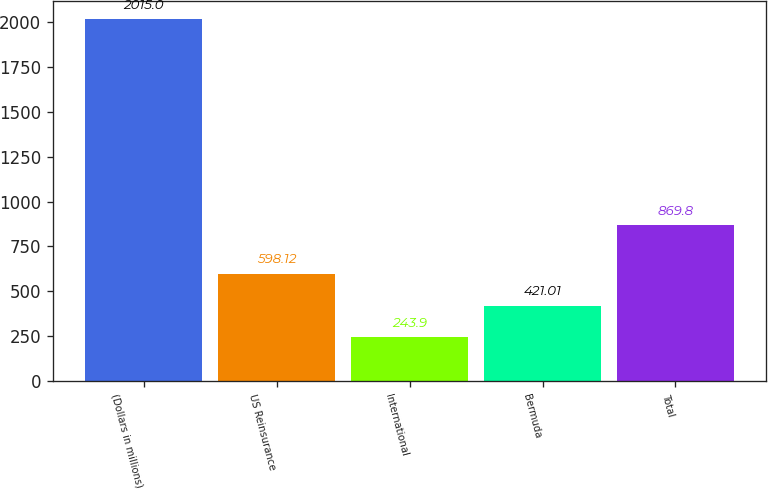<chart> <loc_0><loc_0><loc_500><loc_500><bar_chart><fcel>(Dollars in millions)<fcel>US Reinsurance<fcel>International<fcel>Bermuda<fcel>Total<nl><fcel>2015<fcel>598.12<fcel>243.9<fcel>421.01<fcel>869.8<nl></chart> 